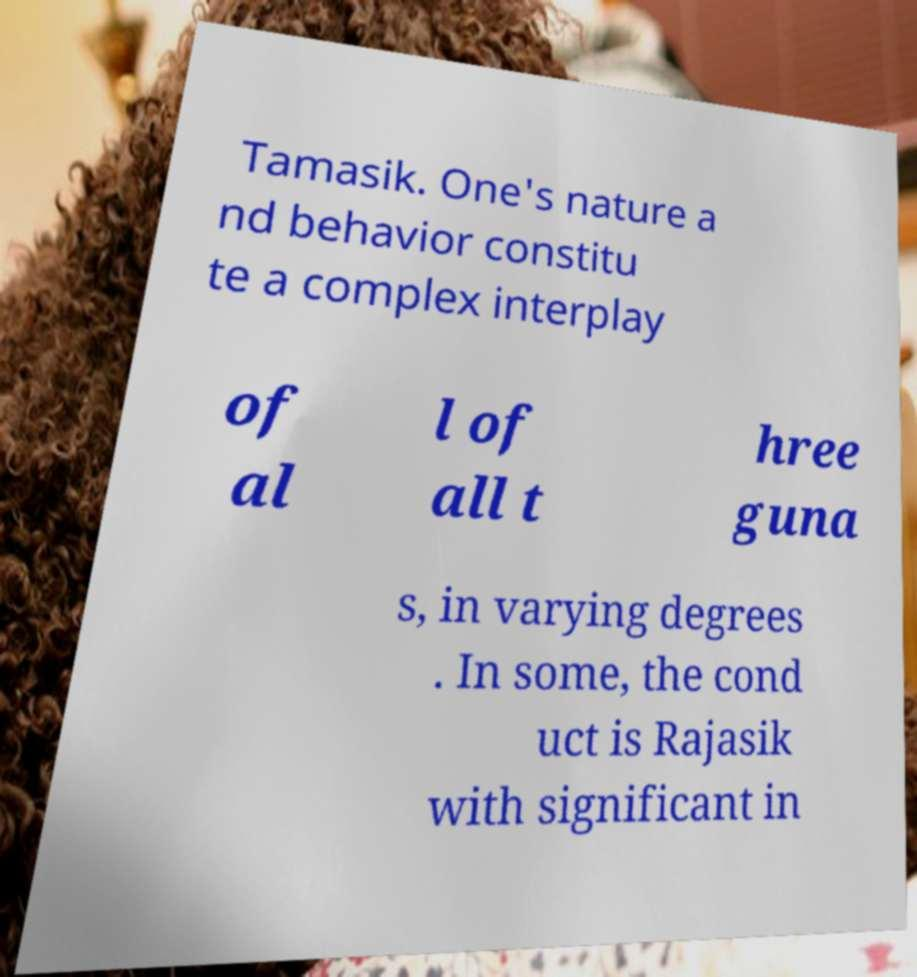Can you accurately transcribe the text from the provided image for me? Tamasik. One's nature a nd behavior constitu te a complex interplay of al l of all t hree guna s, in varying degrees . In some, the cond uct is Rajasik with significant in 